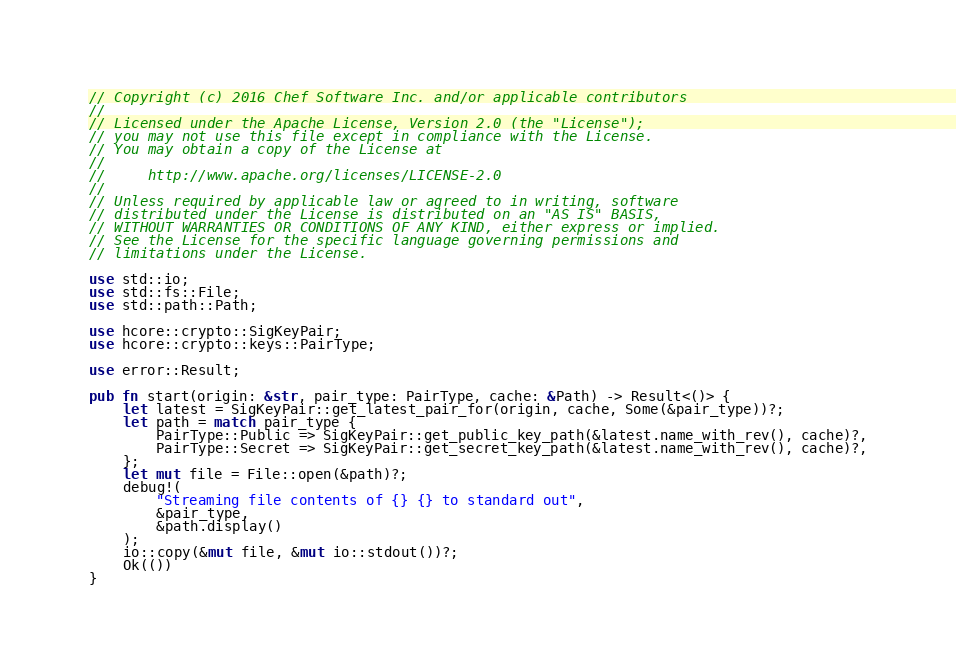Convert code to text. <code><loc_0><loc_0><loc_500><loc_500><_Rust_>// Copyright (c) 2016 Chef Software Inc. and/or applicable contributors
//
// Licensed under the Apache License, Version 2.0 (the "License");
// you may not use this file except in compliance with the License.
// You may obtain a copy of the License at
//
//     http://www.apache.org/licenses/LICENSE-2.0
//
// Unless required by applicable law or agreed to in writing, software
// distributed under the License is distributed on an "AS IS" BASIS,
// WITHOUT WARRANTIES OR CONDITIONS OF ANY KIND, either express or implied.
// See the License for the specific language governing permissions and
// limitations under the License.

use std::io;
use std::fs::File;
use std::path::Path;

use hcore::crypto::SigKeyPair;
use hcore::crypto::keys::PairType;

use error::Result;

pub fn start(origin: &str, pair_type: PairType, cache: &Path) -> Result<()> {
    let latest = SigKeyPair::get_latest_pair_for(origin, cache, Some(&pair_type))?;
    let path = match pair_type {
        PairType::Public => SigKeyPair::get_public_key_path(&latest.name_with_rev(), cache)?,
        PairType::Secret => SigKeyPair::get_secret_key_path(&latest.name_with_rev(), cache)?,
    };
    let mut file = File::open(&path)?;
    debug!(
        "Streaming file contents of {} {} to standard out",
        &pair_type,
        &path.display()
    );
    io::copy(&mut file, &mut io::stdout())?;
    Ok(())
}
</code> 